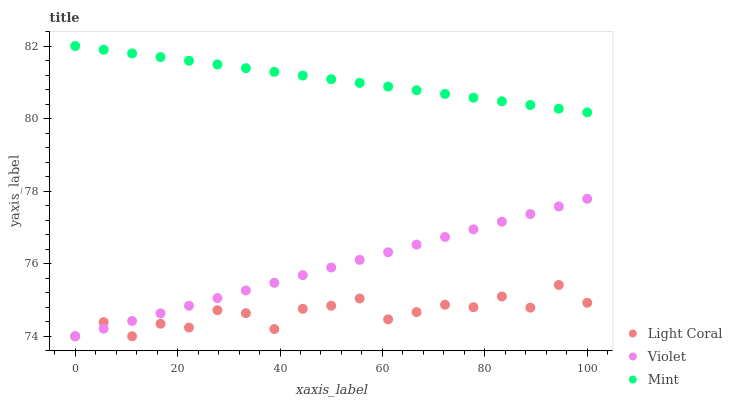Does Light Coral have the minimum area under the curve?
Answer yes or no. Yes. Does Mint have the maximum area under the curve?
Answer yes or no. Yes. Does Violet have the minimum area under the curve?
Answer yes or no. No. Does Violet have the maximum area under the curve?
Answer yes or no. No. Is Violet the smoothest?
Answer yes or no. Yes. Is Light Coral the roughest?
Answer yes or no. Yes. Is Mint the smoothest?
Answer yes or no. No. Is Mint the roughest?
Answer yes or no. No. Does Light Coral have the lowest value?
Answer yes or no. Yes. Does Mint have the lowest value?
Answer yes or no. No. Does Mint have the highest value?
Answer yes or no. Yes. Does Violet have the highest value?
Answer yes or no. No. Is Light Coral less than Mint?
Answer yes or no. Yes. Is Mint greater than Violet?
Answer yes or no. Yes. Does Light Coral intersect Violet?
Answer yes or no. Yes. Is Light Coral less than Violet?
Answer yes or no. No. Is Light Coral greater than Violet?
Answer yes or no. No. Does Light Coral intersect Mint?
Answer yes or no. No. 